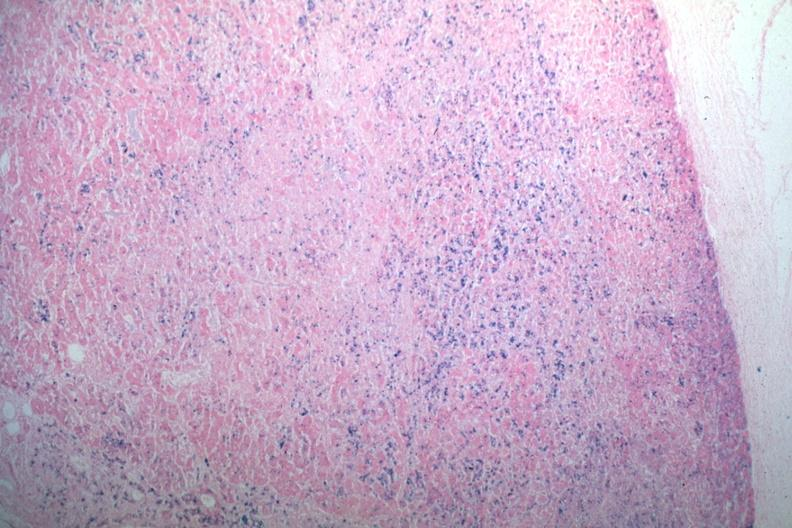what is present?
Answer the question using a single word or phrase. Endocrine 